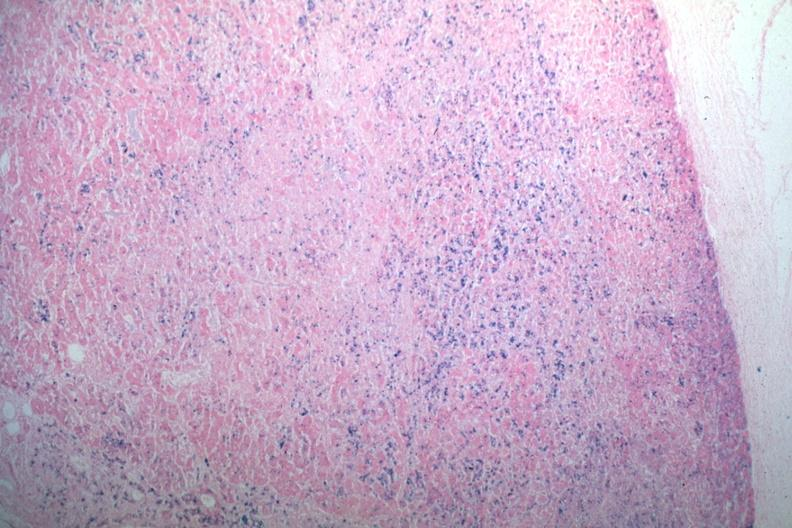what is present?
Answer the question using a single word or phrase. Endocrine 